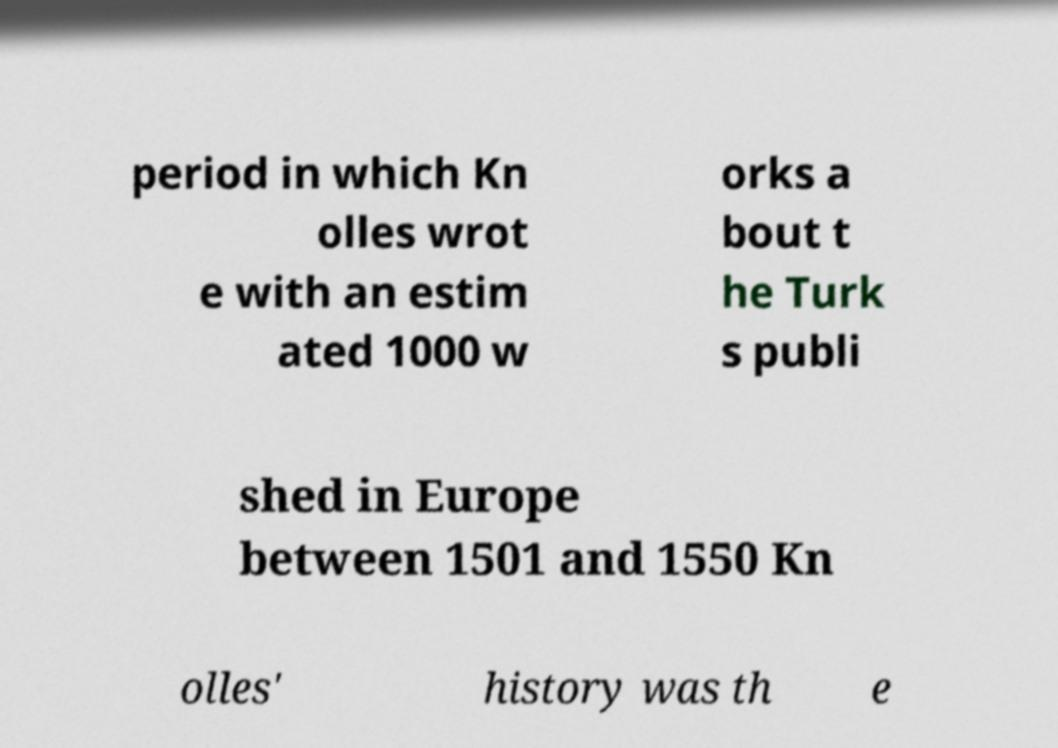What messages or text are displayed in this image? I need them in a readable, typed format. period in which Kn olles wrot e with an estim ated 1000 w orks a bout t he Turk s publi shed in Europe between 1501 and 1550 Kn olles' history was th e 